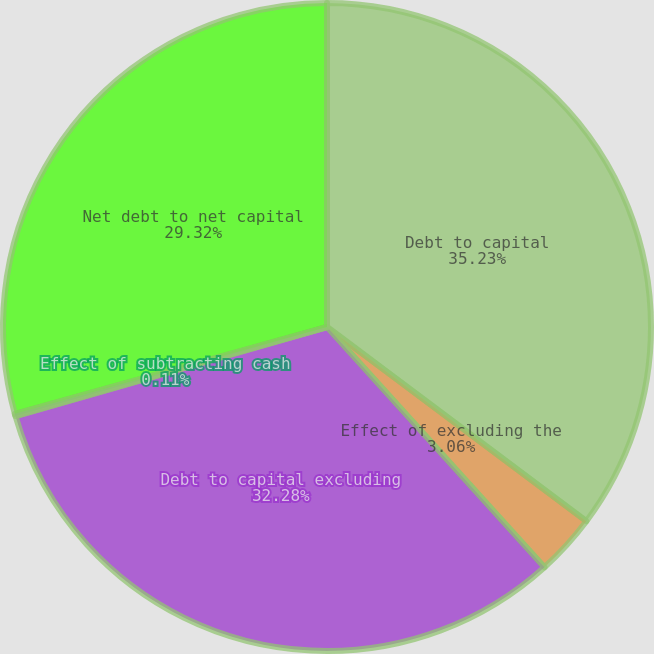Convert chart. <chart><loc_0><loc_0><loc_500><loc_500><pie_chart><fcel>Debt to capital<fcel>Effect of excluding the<fcel>Debt to capital excluding<fcel>Effect of subtracting cash<fcel>Net debt to net capital<nl><fcel>35.23%<fcel>3.06%<fcel>32.28%<fcel>0.11%<fcel>29.32%<nl></chart> 